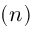<formula> <loc_0><loc_0><loc_500><loc_500>( n )</formula> 